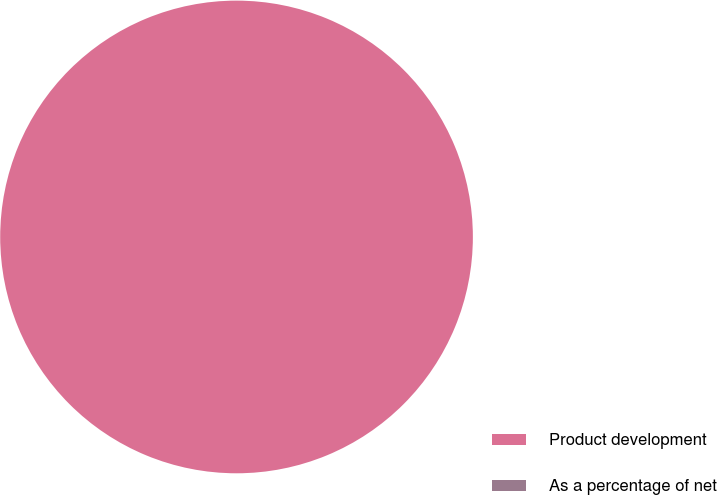Convert chart. <chart><loc_0><loc_0><loc_500><loc_500><pie_chart><fcel>Product development<fcel>As a percentage of net<nl><fcel>100.0%<fcel>0.0%<nl></chart> 